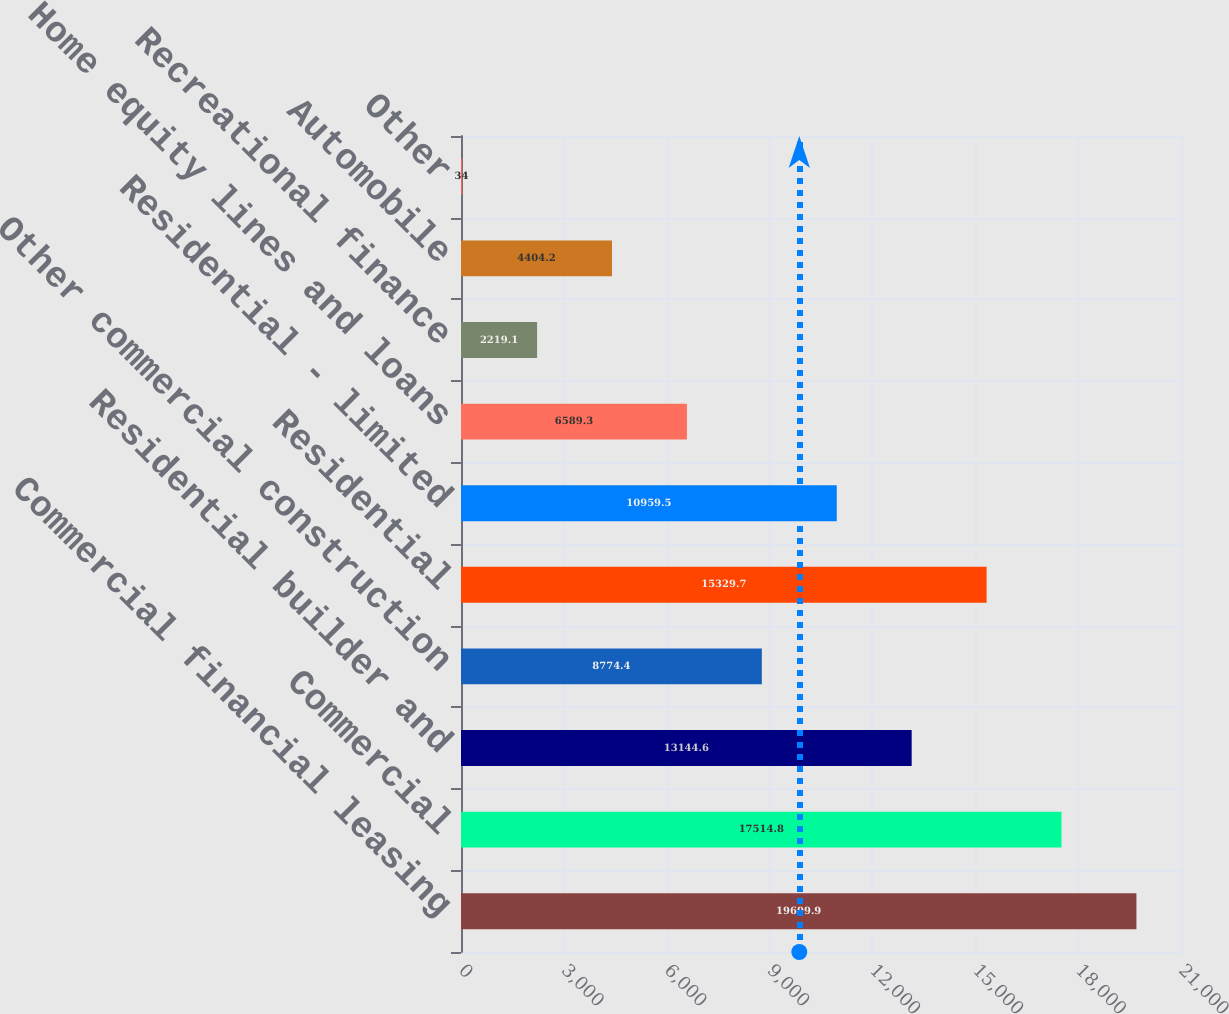<chart> <loc_0><loc_0><loc_500><loc_500><bar_chart><fcel>Commercial financial leasing<fcel>Commercial<fcel>Residential builder and<fcel>Other commercial construction<fcel>Residential<fcel>Residential - limited<fcel>Home equity lines and loans<fcel>Recreational finance<fcel>Automobile<fcel>Other<nl><fcel>19699.9<fcel>17514.8<fcel>13144.6<fcel>8774.4<fcel>15329.7<fcel>10959.5<fcel>6589.3<fcel>2219.1<fcel>4404.2<fcel>34<nl></chart> 